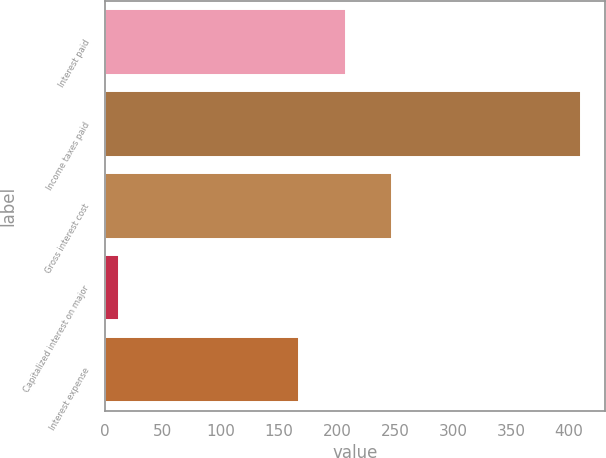Convert chart. <chart><loc_0><loc_0><loc_500><loc_500><bar_chart><fcel>Interest paid<fcel>Income taxes paid<fcel>Gross interest cost<fcel>Capitalized interest on major<fcel>Interest expense<nl><fcel>207.59<fcel>410.4<fcel>247.38<fcel>12.5<fcel>167.8<nl></chart> 